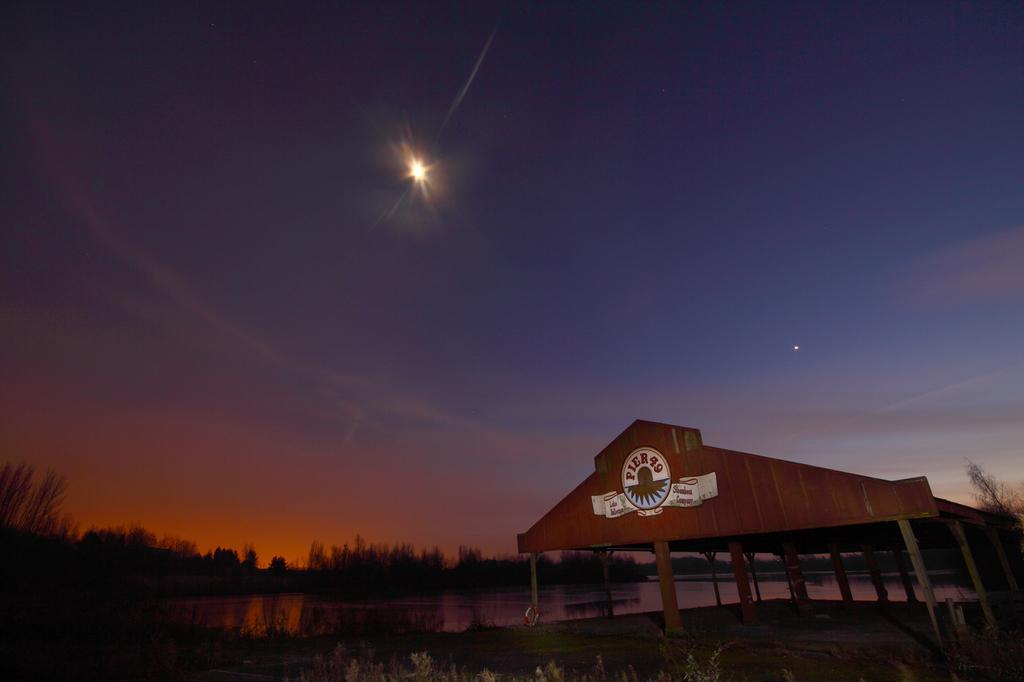What celestial objects can be seen in the sky in the image? Stars are visible in the sky in the image. What else is present in the sky besides stars? The sky contains clouds. What type of vegetation is present in the image? There are trees in the image. What is the main feature of the landscape in the image? There is a watershed in the image. What is visible at the bottom of the image? The ground is visible in the image. Can you see a stick being used by a monkey in the image? There is no stick or monkey present in the image. What type of rest can be seen in the image? There is no rest or resting area visible in the image. 